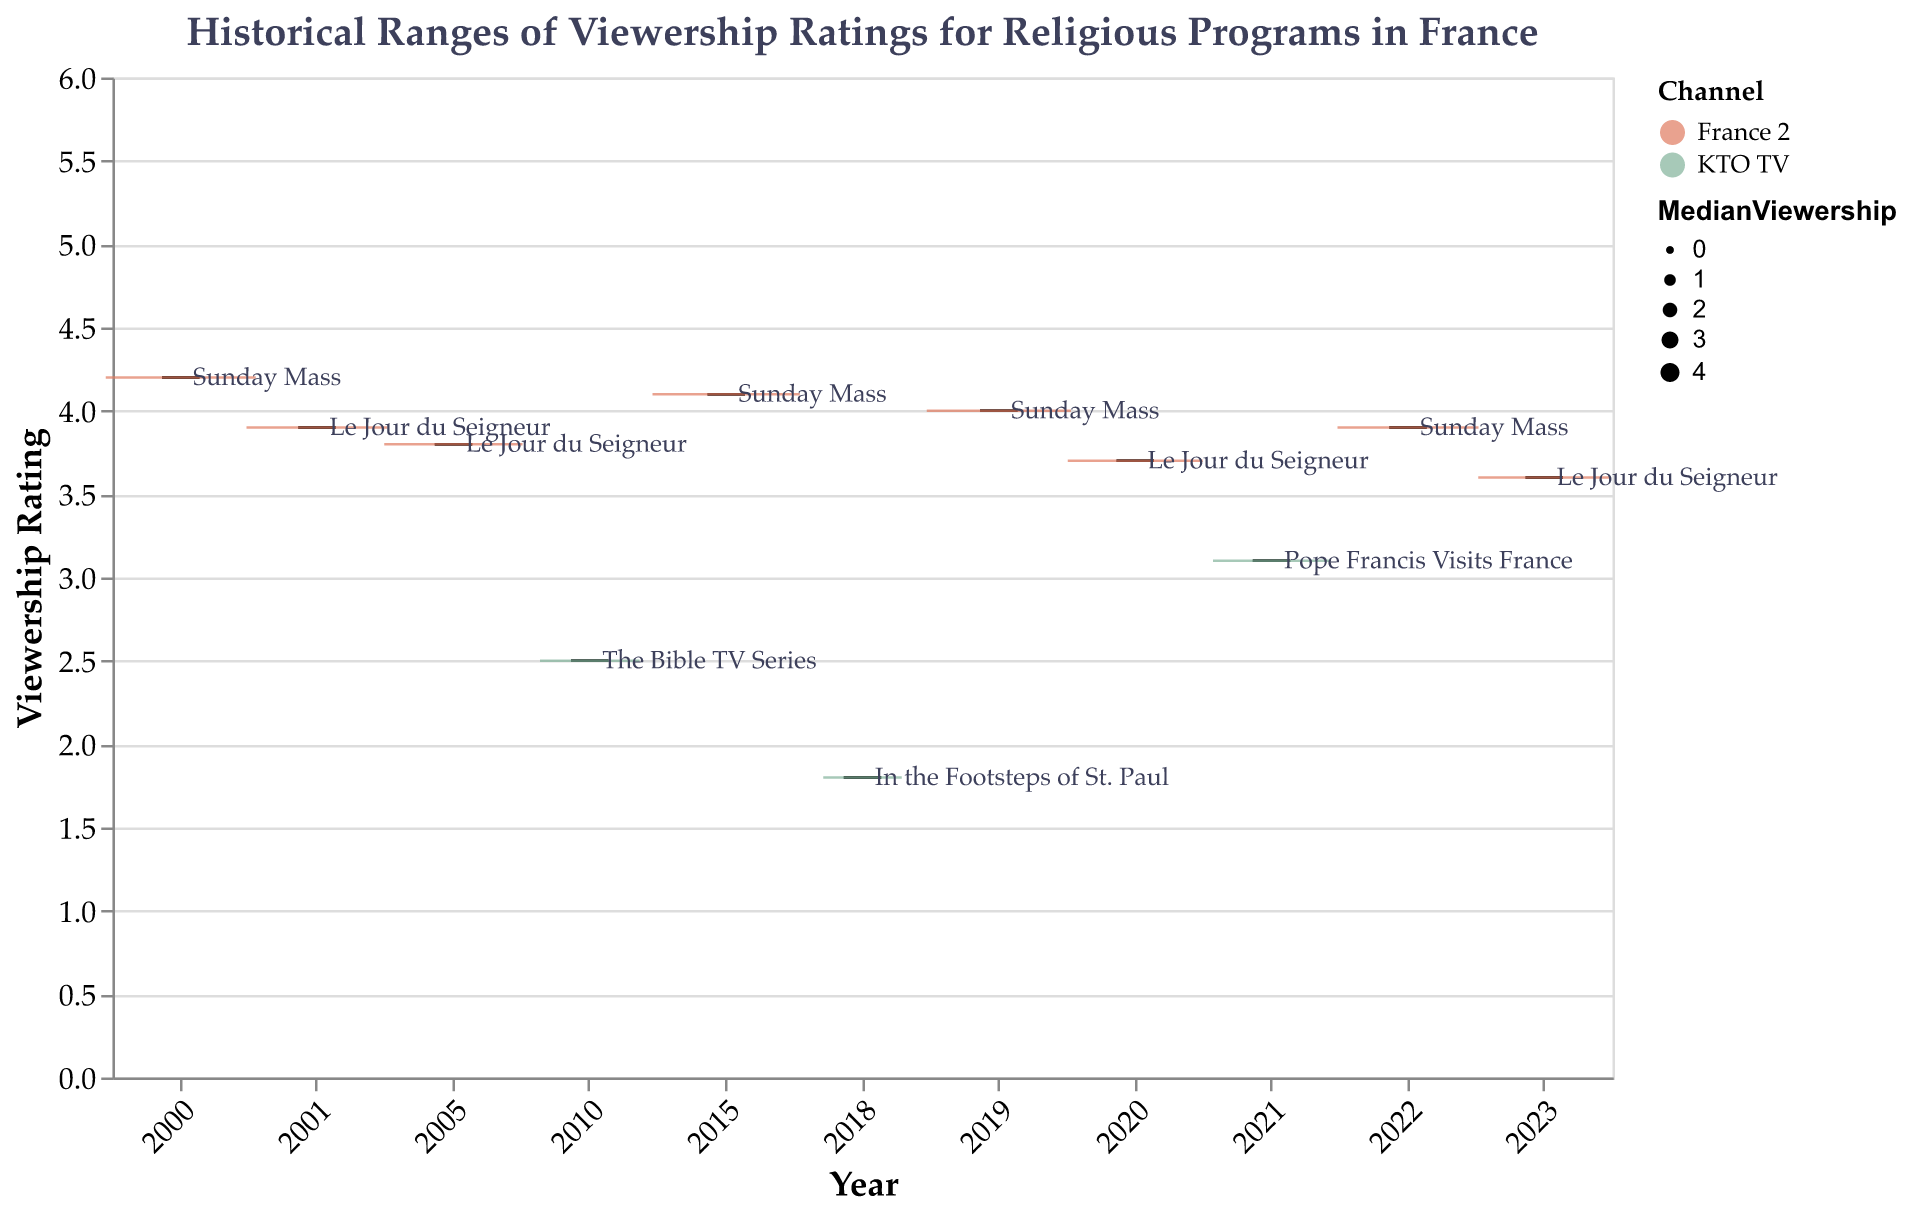How many different religious programs are shown in the figure? There are unique labels next to each boxplot, indicating the names of different programs. Counting these unique labels gives the number of programs.
Answer: 7 Which program had the highest median viewership rating in the given period? Identify the box with the highest central line (indicating the median) by reading the median values from the plot's corresponding axis. The highest is "Sunday Mass" in 2000 with a median viewership of 4.2.
Answer: Sunday Mass What is the median viewership rating for "Le Jour du Seigneur" in 2001 compared to 2023? Locate the boxplots for "Le Jour du Seigneur" in 2001 and 2023 and read their respective median values. In 2001, it is 3.9, and in 2023, it is 3.6.
Answer: Higher in 2001; 3.9 vs. 3.6 Which channel has the most programs listed? Count the number of programs associated with France 2 and KTO TV by observing and summing the labels associated with each channel color. France 2 appears more frequently.
Answer: France 2 Examine the viewership trend for "Sunday Mass" from 2000 to 2022. How does the median viewership rating change over time? Track the boxplots for "Sunday Mass" over the years. The medians are 4.2 (2000), 4.1 (2015), 4.0 (2019), and 3.9 (2022). The trend shows a slight decrease over time.
Answer: Decreases slightly Which program and year combination has the widest range of viewership ratings? Look for the boxplot with the greatest distance between minimum and maximum whiskers. "Sunday Mass" in 2000 has the widest range from 2.1 to 5.6.
Answer: Sunday Mass, 2000 How does the viewership rating range of "The Bible TV Series" compare to "Pope Francis Visits France"? Compare the ranges (min to max values) of the respective boxplots. "The Bible TV Series" ranges from 1.6 to 3.3, whereas "Pope Francis Visits France" ranges from 2.0 to 4.0.
Answer: Wider range for Pope Francis Visits France In which year did "Le Jour du Seigneur" have the lowest median viewership rating? Find the boxplot for "Le Jour du Seigneur" in each of its years and compare their median values. The lowest is 3.6 in 2023.
Answer: 2023 What is the interquartile range (IQR) of "In the Footsteps of St. Paul" in 2018? The IQR is the difference between the upper and lower quartiles. For the 2018 program, it is 2.1 - 1.3.
Answer: 0.8 Which programs were broadcasted on KTO TV, and how do their median viewership ratings differ? Identify programs associated with KTO TV and compare their median viewerships. They are "The Bible TV Series" (2.5), "In the Footsteps of St. Paul" (1.8), and "Pope Francis Visits France" (3.1).
Answer: The Bible TV Series: 2.5, In the Footsteps of St. Paul: 1.8, Pope Francis Visits France: 3.1 